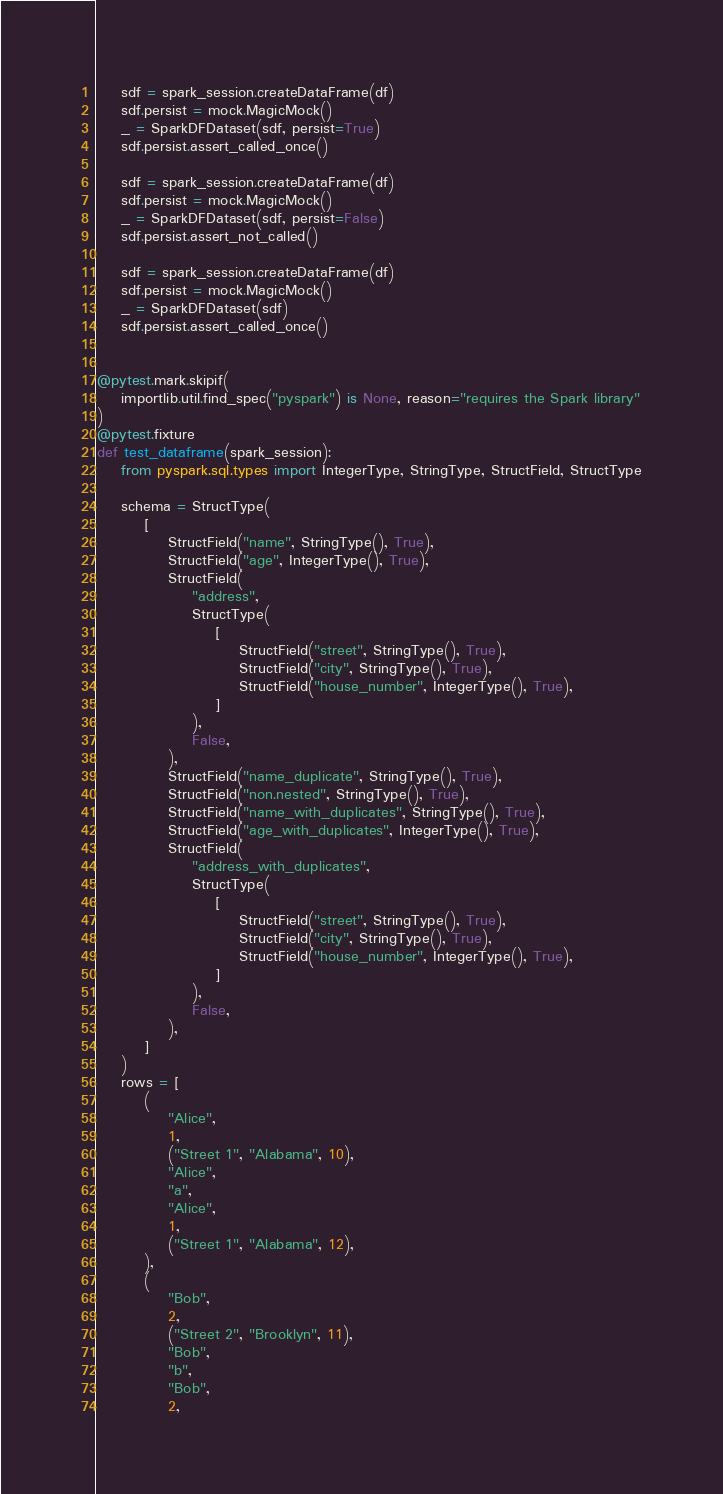<code> <loc_0><loc_0><loc_500><loc_500><_Python_>    sdf = spark_session.createDataFrame(df)
    sdf.persist = mock.MagicMock()
    _ = SparkDFDataset(sdf, persist=True)
    sdf.persist.assert_called_once()

    sdf = spark_session.createDataFrame(df)
    sdf.persist = mock.MagicMock()
    _ = SparkDFDataset(sdf, persist=False)
    sdf.persist.assert_not_called()

    sdf = spark_session.createDataFrame(df)
    sdf.persist = mock.MagicMock()
    _ = SparkDFDataset(sdf)
    sdf.persist.assert_called_once()


@pytest.mark.skipif(
    importlib.util.find_spec("pyspark") is None, reason="requires the Spark library"
)
@pytest.fixture
def test_dataframe(spark_session):
    from pyspark.sql.types import IntegerType, StringType, StructField, StructType

    schema = StructType(
        [
            StructField("name", StringType(), True),
            StructField("age", IntegerType(), True),
            StructField(
                "address",
                StructType(
                    [
                        StructField("street", StringType(), True),
                        StructField("city", StringType(), True),
                        StructField("house_number", IntegerType(), True),
                    ]
                ),
                False,
            ),
            StructField("name_duplicate", StringType(), True),
            StructField("non.nested", StringType(), True),
            StructField("name_with_duplicates", StringType(), True),
            StructField("age_with_duplicates", IntegerType(), True),
            StructField(
                "address_with_duplicates",
                StructType(
                    [
                        StructField("street", StringType(), True),
                        StructField("city", StringType(), True),
                        StructField("house_number", IntegerType(), True),
                    ]
                ),
                False,
            ),
        ]
    )
    rows = [
        (
            "Alice",
            1,
            ("Street 1", "Alabama", 10),
            "Alice",
            "a",
            "Alice",
            1,
            ("Street 1", "Alabama", 12),
        ),
        (
            "Bob",
            2,
            ("Street 2", "Brooklyn", 11),
            "Bob",
            "b",
            "Bob",
            2,</code> 